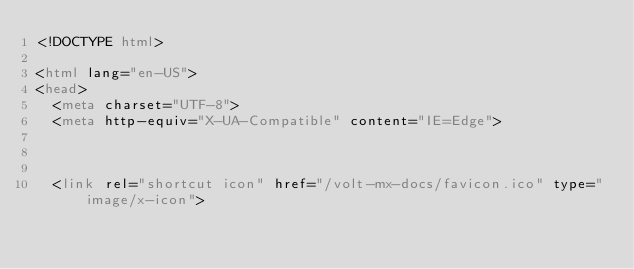Convert code to text. <code><loc_0><loc_0><loc_500><loc_500><_HTML_><!DOCTYPE html>

<html lang="en-US">
<head>
  <meta charset="UTF-8">
  <meta http-equiv="X-UA-Compatible" content="IE=Edge">

  

  <link rel="shortcut icon" href="/volt-mx-docs/favicon.ico" type="image/x-icon">
</code> 